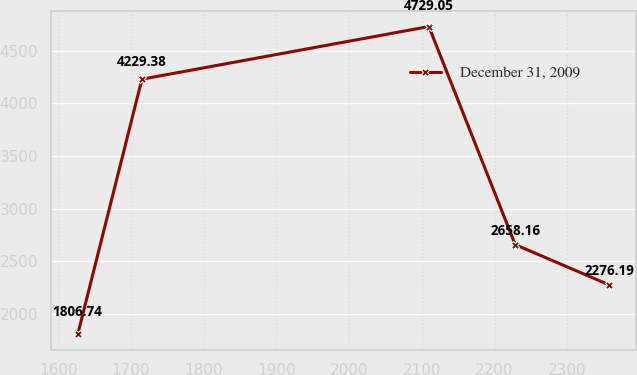Convert chart. <chart><loc_0><loc_0><loc_500><loc_500><line_chart><ecel><fcel>December 31, 2009<nl><fcel>1626.69<fcel>1806.74<nl><fcel>1714.97<fcel>4229.38<nl><fcel>2109.61<fcel>4729.05<nl><fcel>2228.35<fcel>2658.16<nl><fcel>2357.42<fcel>2276.19<nl></chart> 